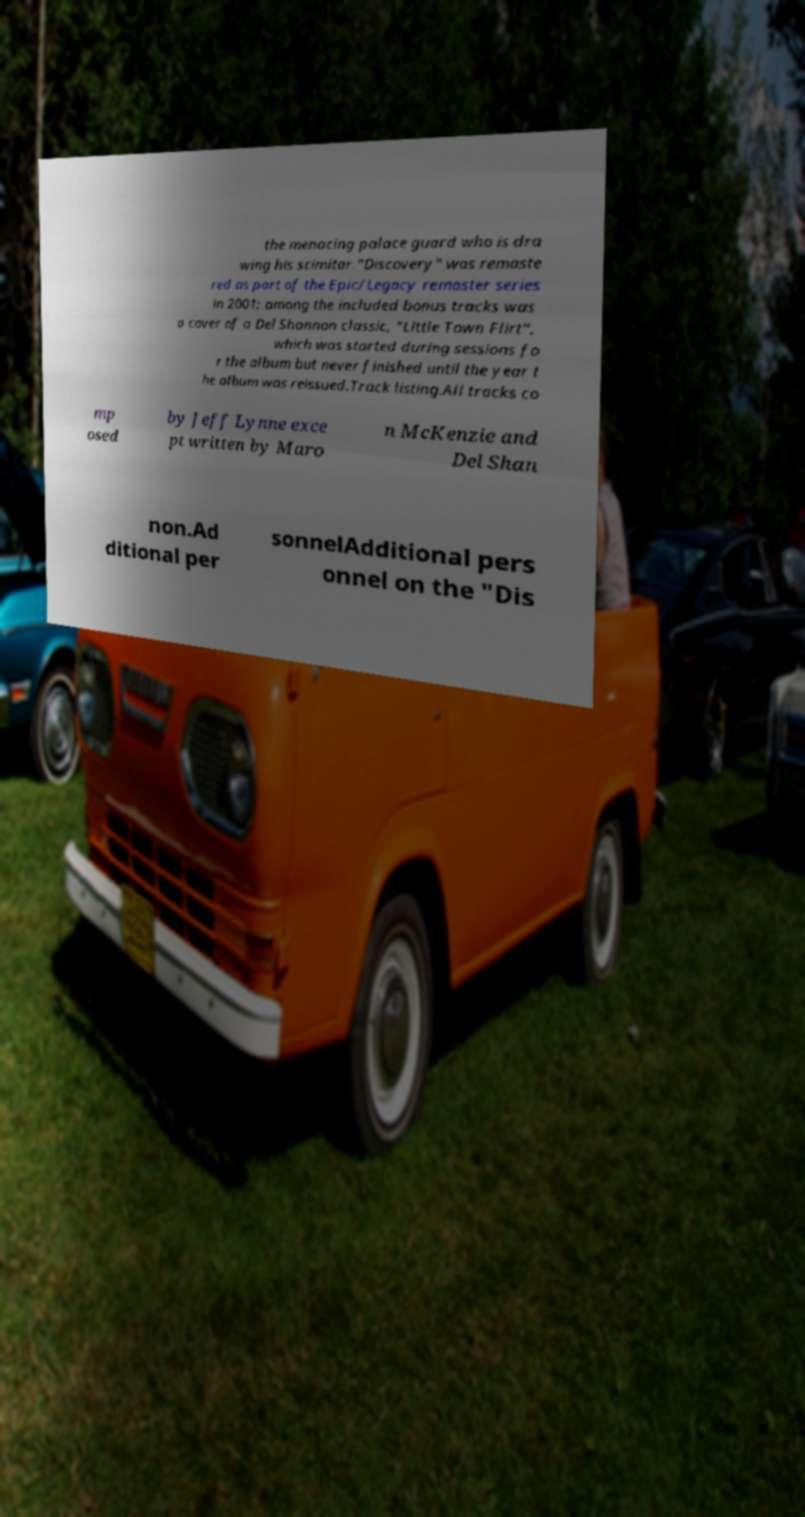There's text embedded in this image that I need extracted. Can you transcribe it verbatim? the menacing palace guard who is dra wing his scimitar."Discovery" was remaste red as part of the Epic/Legacy remaster series in 2001; among the included bonus tracks was a cover of a Del Shannon classic, "Little Town Flirt", which was started during sessions fo r the album but never finished until the year t he album was reissued.Track listing.All tracks co mp osed by Jeff Lynne exce pt written by Maro n McKenzie and Del Shan non.Ad ditional per sonnelAdditional pers onnel on the "Dis 